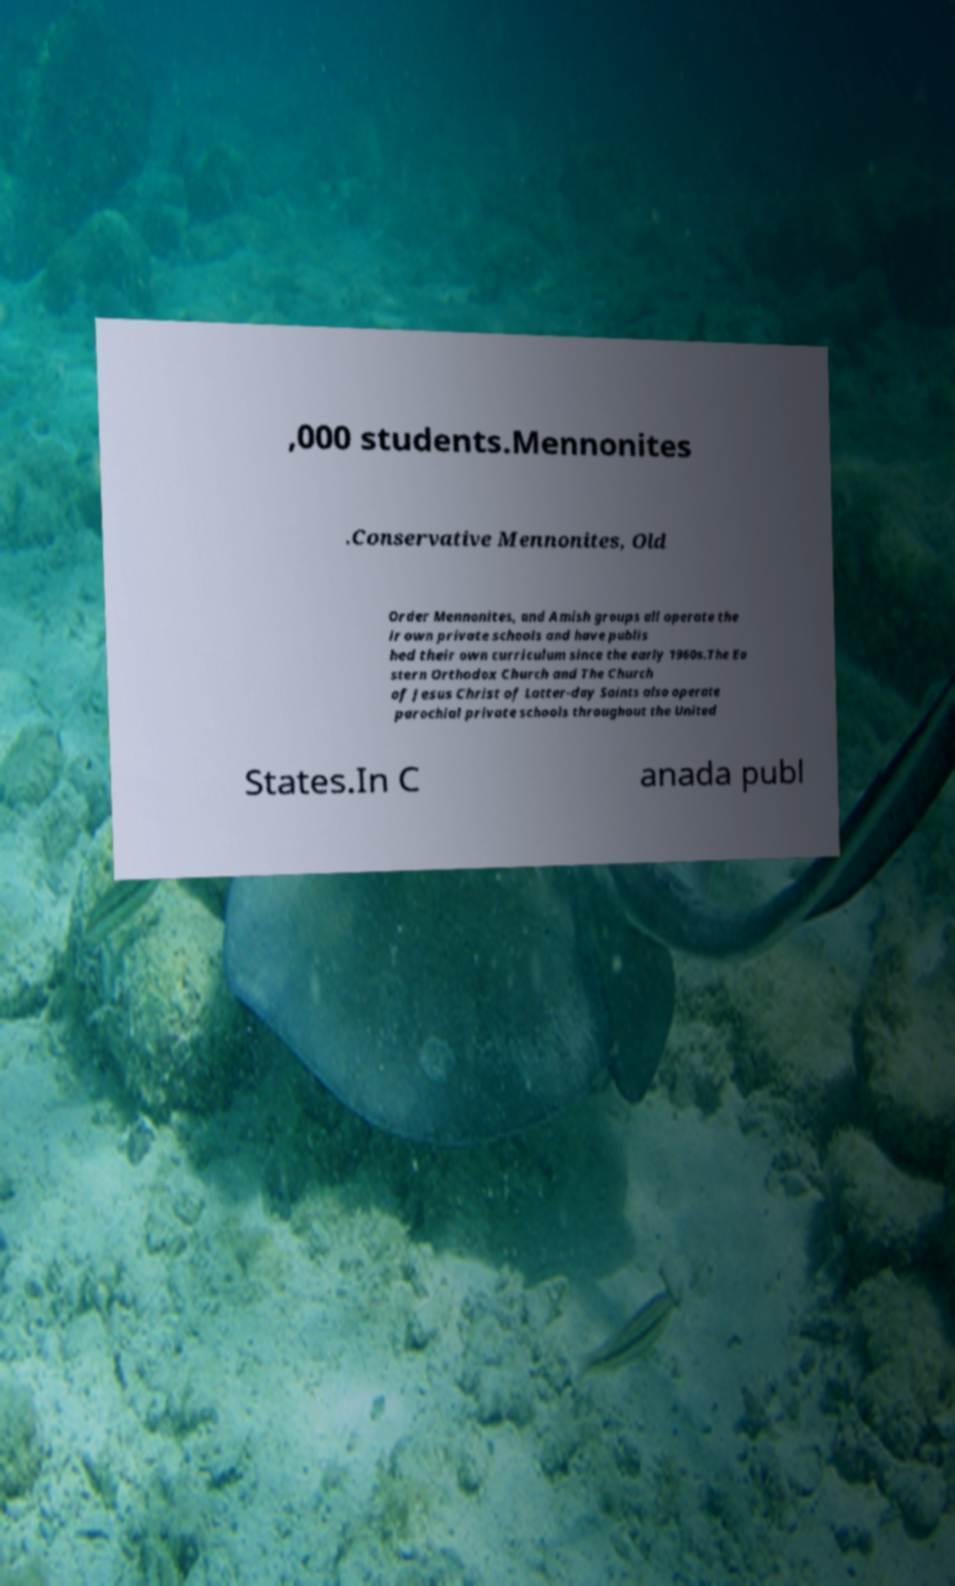What messages or text are displayed in this image? I need them in a readable, typed format. ,000 students.Mennonites .Conservative Mennonites, Old Order Mennonites, and Amish groups all operate the ir own private schools and have publis hed their own curriculum since the early 1960s.The Ea stern Orthodox Church and The Church of Jesus Christ of Latter-day Saints also operate parochial private schools throughout the United States.In C anada publ 